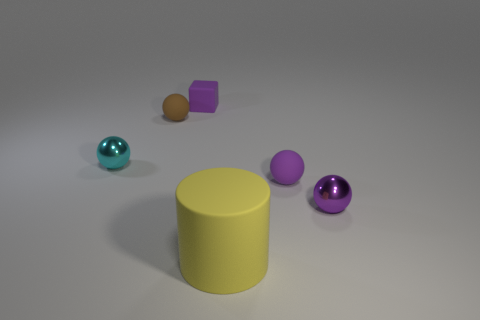Subtract all tiny purple metal balls. How many balls are left? 3 Add 1 brown things. How many objects exist? 7 Subtract all brown spheres. How many spheres are left? 3 Subtract all spheres. How many objects are left? 2 Subtract 2 spheres. How many spheres are left? 2 Subtract all cyan blocks. How many red cylinders are left? 0 Subtract all cyan spheres. Subtract all brown rubber balls. How many objects are left? 4 Add 4 yellow matte things. How many yellow matte things are left? 5 Add 3 small things. How many small things exist? 8 Subtract 0 blue balls. How many objects are left? 6 